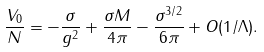Convert formula to latex. <formula><loc_0><loc_0><loc_500><loc_500>\frac { V _ { 0 } } { N } = - \frac { \sigma } { g ^ { 2 } } + \frac { \sigma M } { 4 \pi } - \frac { \sigma ^ { 3 / 2 } } { 6 \pi } + O ( 1 / \Lambda ) .</formula> 